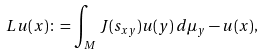Convert formula to latex. <formula><loc_0><loc_0><loc_500><loc_500>L u ( x ) \colon = \int _ { M } J ( s _ { x y } ) u ( y ) \, d \mu _ { y } - u ( x ) ,</formula> 